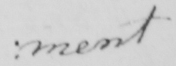Please provide the text content of this handwritten line. ment 